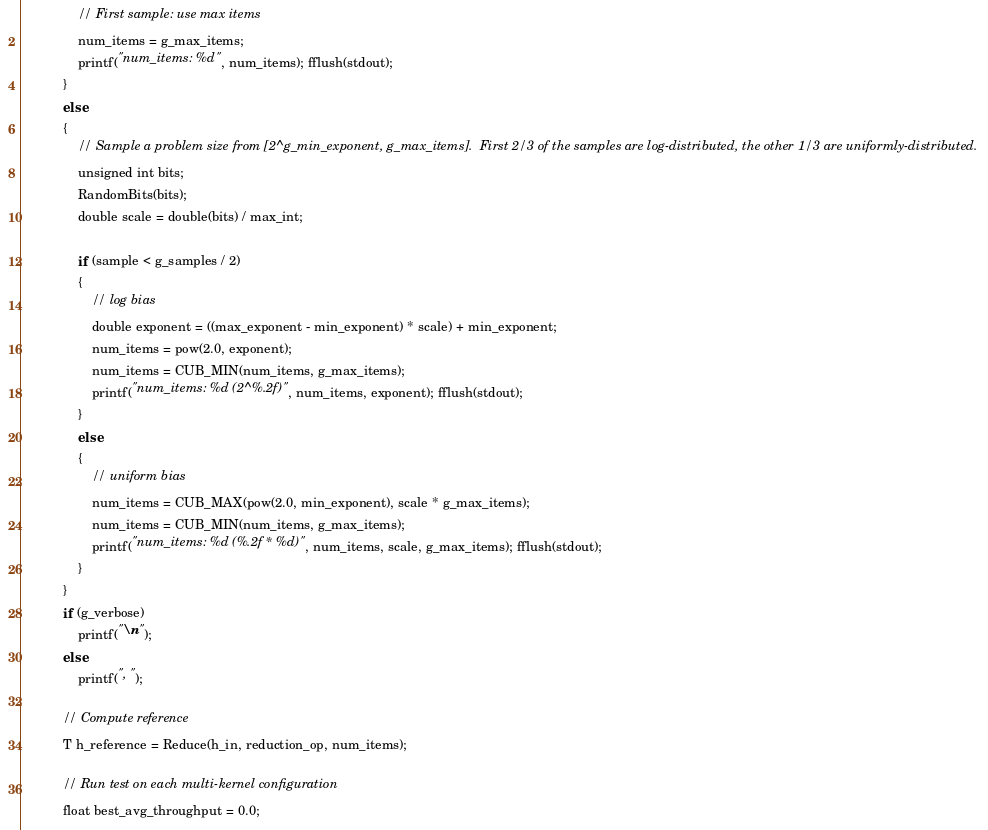<code> <loc_0><loc_0><loc_500><loc_500><_Cuda_>                // First sample: use max items
                num_items = g_max_items;
                printf("num_items: %d", num_items); fflush(stdout);
            }
            else
            {
                // Sample a problem size from [2^g_min_exponent, g_max_items].  First 2/3 of the samples are log-distributed, the other 1/3 are uniformly-distributed.
                unsigned int bits;
                RandomBits(bits);
                double scale = double(bits) / max_int;

                if (sample < g_samples / 2)
                {
                    // log bias
                    double exponent = ((max_exponent - min_exponent) * scale) + min_exponent;
                    num_items = pow(2.0, exponent);
                    num_items = CUB_MIN(num_items, g_max_items);
                    printf("num_items: %d (2^%.2f)", num_items, exponent); fflush(stdout);
                }
                else
                {
                    // uniform bias
                    num_items = CUB_MAX(pow(2.0, min_exponent), scale * g_max_items);
                    num_items = CUB_MIN(num_items, g_max_items);
                    printf("num_items: %d (%.2f * %d)", num_items, scale, g_max_items); fflush(stdout);
                }
            }
            if (g_verbose)
                printf("\n");
            else
                printf(", ");

            // Compute reference
            T h_reference = Reduce(h_in, reduction_op, num_items);

            // Run test on each multi-kernel configuration
            float best_avg_throughput = 0.0;</code> 